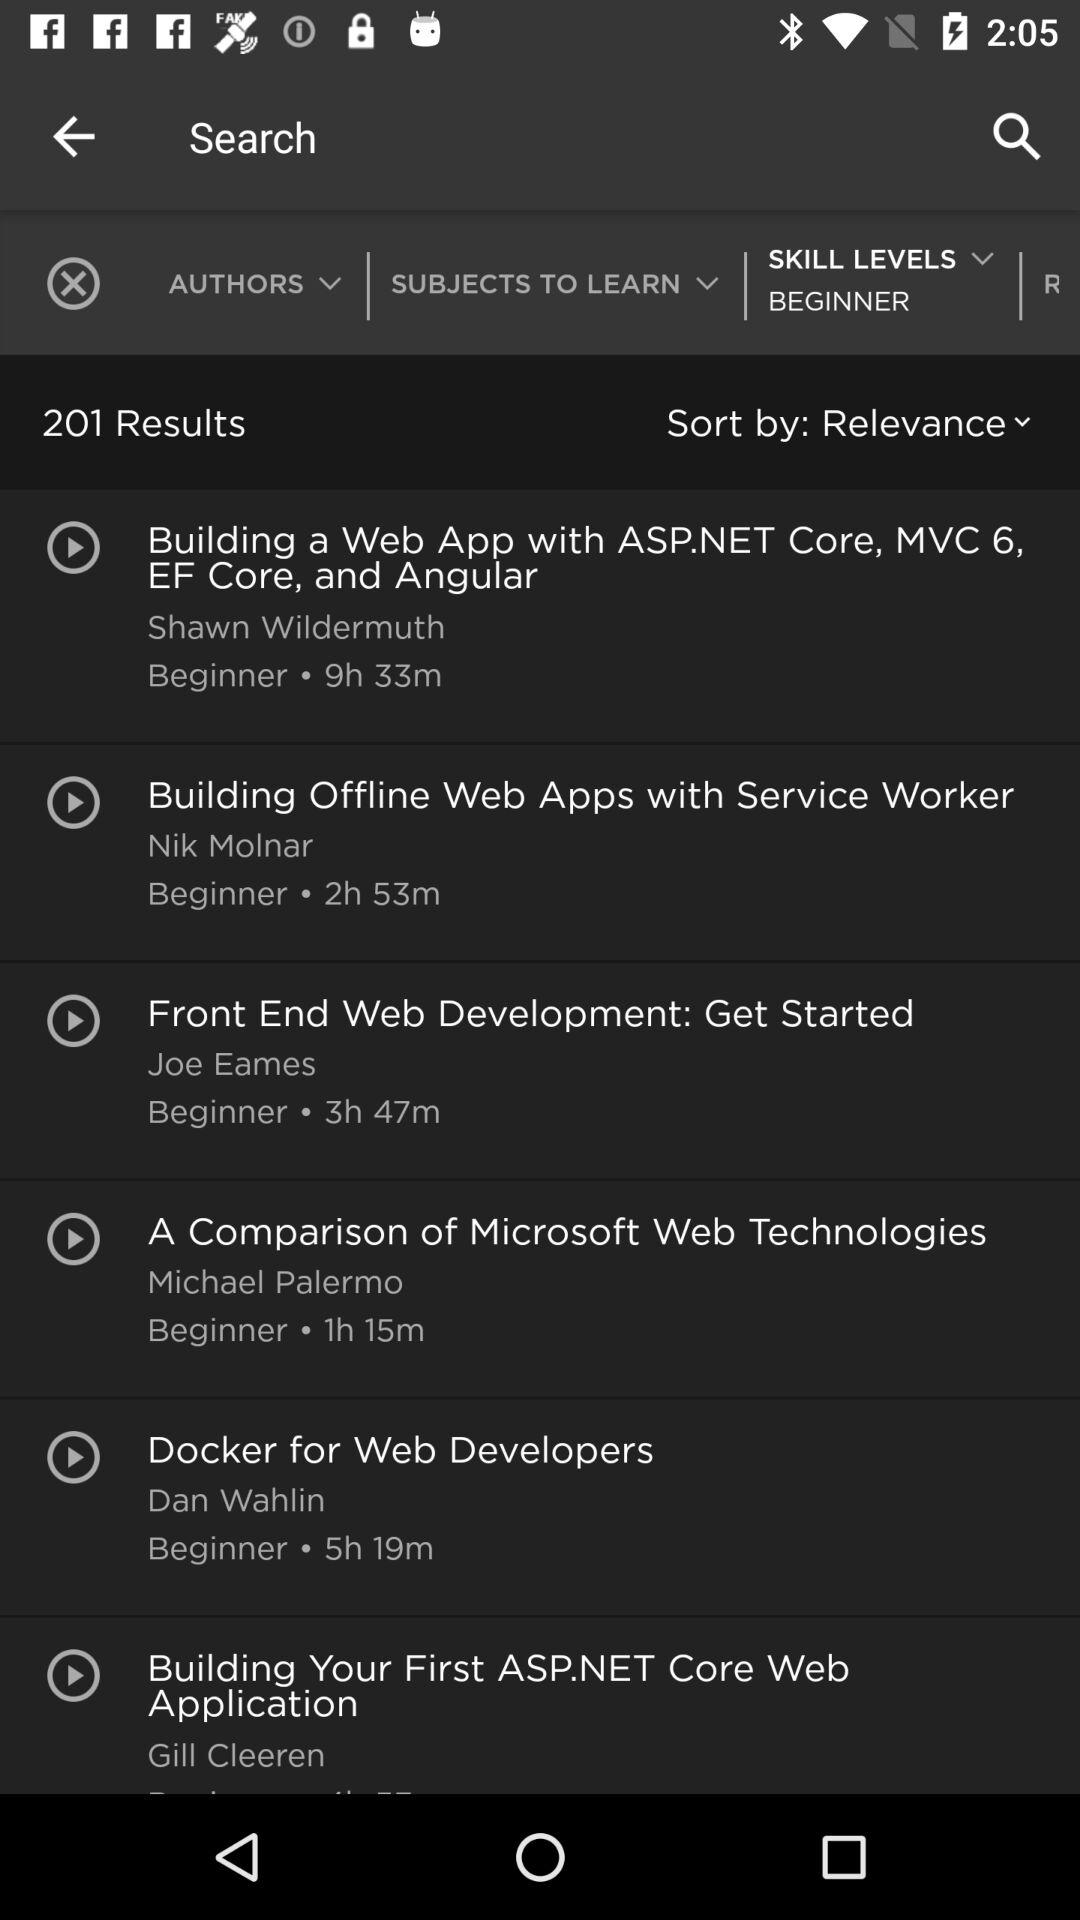How much time does it take a beginner to finish the topic "Building offline web apps with service workers"? The beginner takes 2 hours and 53 minutes. 